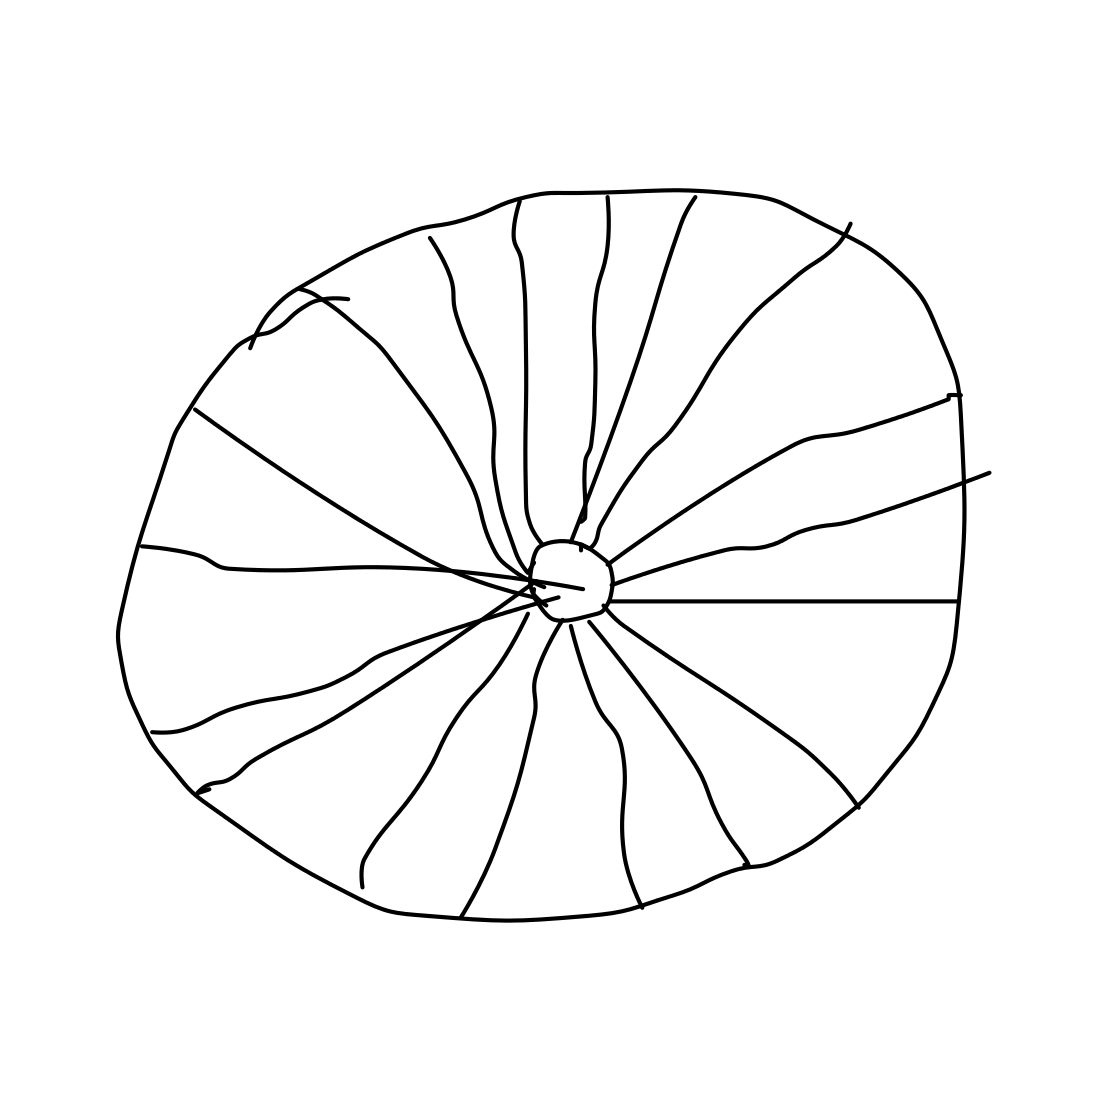Is this a wheel in the image? Yes, the image depicts a simple line drawing of a wheel. The pattern of lines radiating from the center outwards is typical of representations of wheels, suggesting spokes or divisions that are characteristic of a wheel's design. 